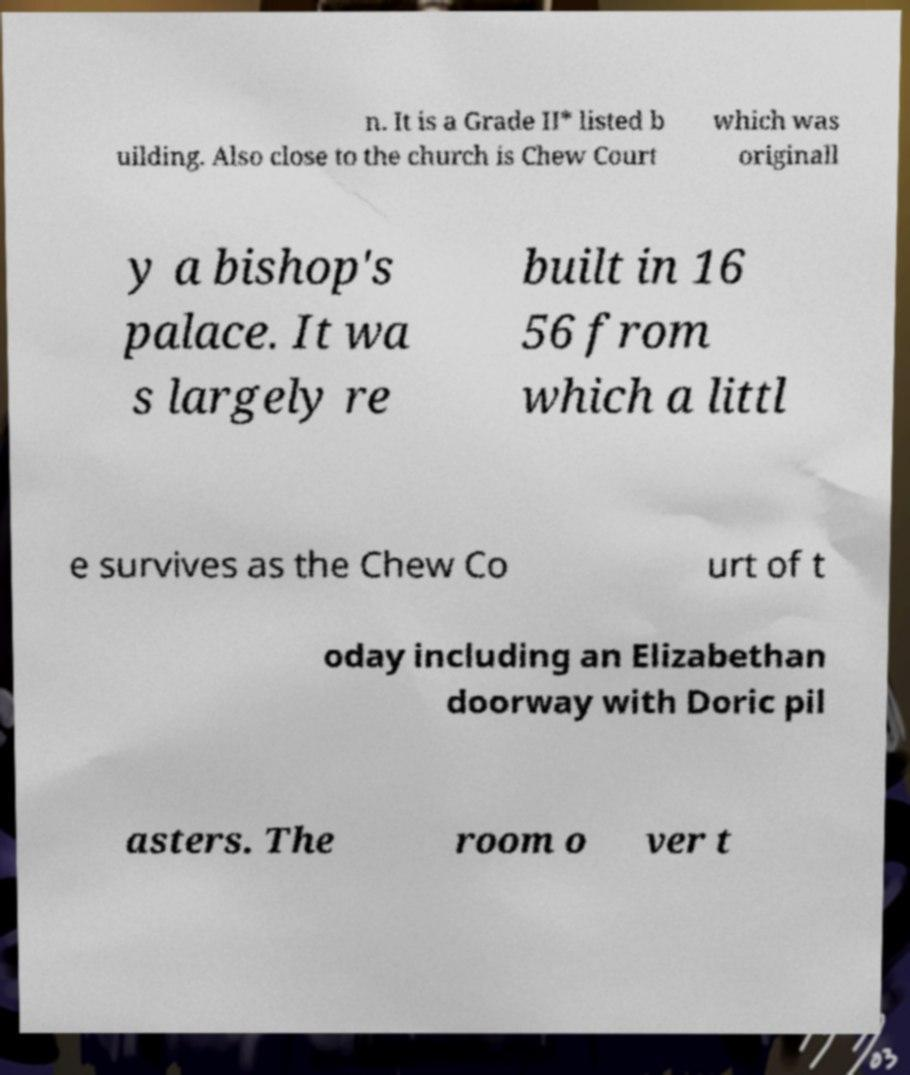Could you extract and type out the text from this image? n. It is a Grade II* listed b uilding. Also close to the church is Chew Court which was originall y a bishop's palace. It wa s largely re built in 16 56 from which a littl e survives as the Chew Co urt of t oday including an Elizabethan doorway with Doric pil asters. The room o ver t 